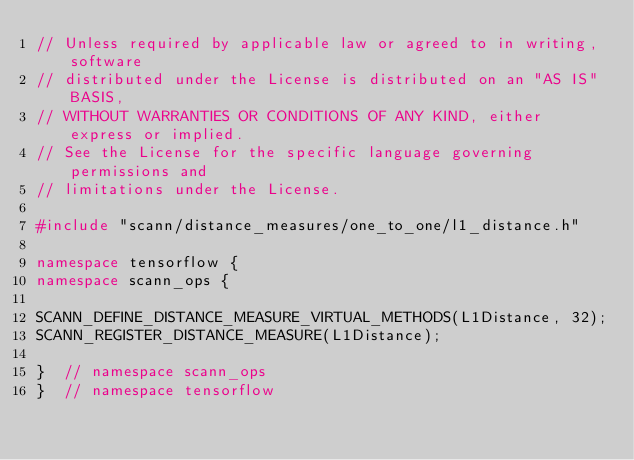<code> <loc_0><loc_0><loc_500><loc_500><_C++_>// Unless required by applicable law or agreed to in writing, software
// distributed under the License is distributed on an "AS IS" BASIS,
// WITHOUT WARRANTIES OR CONDITIONS OF ANY KIND, either express or implied.
// See the License for the specific language governing permissions and
// limitations under the License.

#include "scann/distance_measures/one_to_one/l1_distance.h"

namespace tensorflow {
namespace scann_ops {

SCANN_DEFINE_DISTANCE_MEASURE_VIRTUAL_METHODS(L1Distance, 32);
SCANN_REGISTER_DISTANCE_MEASURE(L1Distance);

}  // namespace scann_ops
}  // namespace tensorflow
</code> 